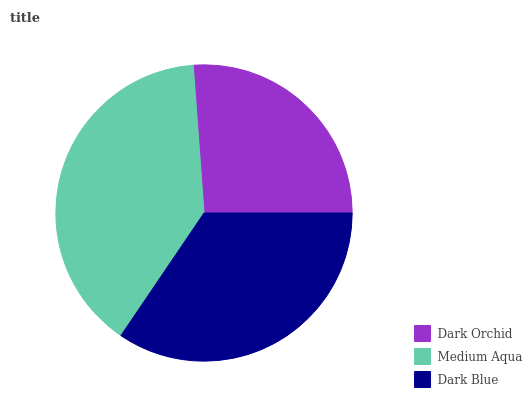Is Dark Orchid the minimum?
Answer yes or no. Yes. Is Medium Aqua the maximum?
Answer yes or no. Yes. Is Dark Blue the minimum?
Answer yes or no. No. Is Dark Blue the maximum?
Answer yes or no. No. Is Medium Aqua greater than Dark Blue?
Answer yes or no. Yes. Is Dark Blue less than Medium Aqua?
Answer yes or no. Yes. Is Dark Blue greater than Medium Aqua?
Answer yes or no. No. Is Medium Aqua less than Dark Blue?
Answer yes or no. No. Is Dark Blue the high median?
Answer yes or no. Yes. Is Dark Blue the low median?
Answer yes or no. Yes. Is Medium Aqua the high median?
Answer yes or no. No. Is Dark Orchid the low median?
Answer yes or no. No. 